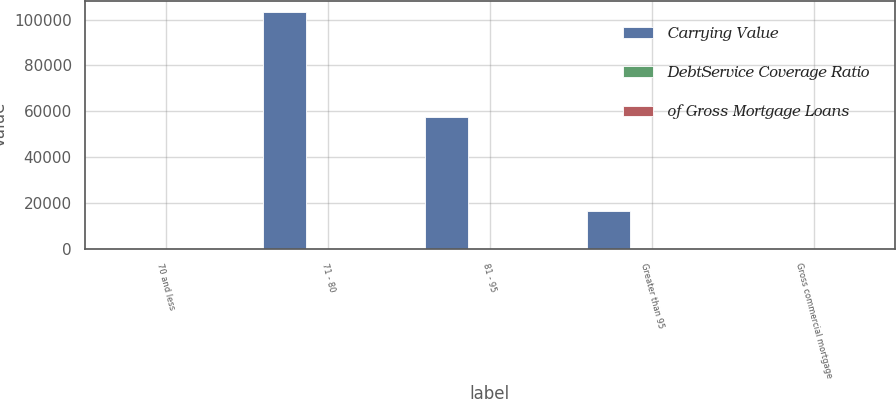Convert chart to OTSL. <chart><loc_0><loc_0><loc_500><loc_500><stacked_bar_chart><ecel><fcel>70 and less<fcel>71 - 80<fcel>81 - 95<fcel>Greater than 95<fcel>Gross commercial mortgage<nl><fcel>Carrying Value<fcel>4.3<fcel>103152<fcel>57413<fcel>16550<fcel>4.3<nl><fcel>DebtService Coverage Ratio<fcel>86.6<fcel>7.8<fcel>4.3<fcel>1.3<fcel>100<nl><fcel>of Gross Mortgage Loans<fcel>1.95<fcel>1.3<fcel>1.04<fcel>1.02<fcel>1.85<nl></chart> 